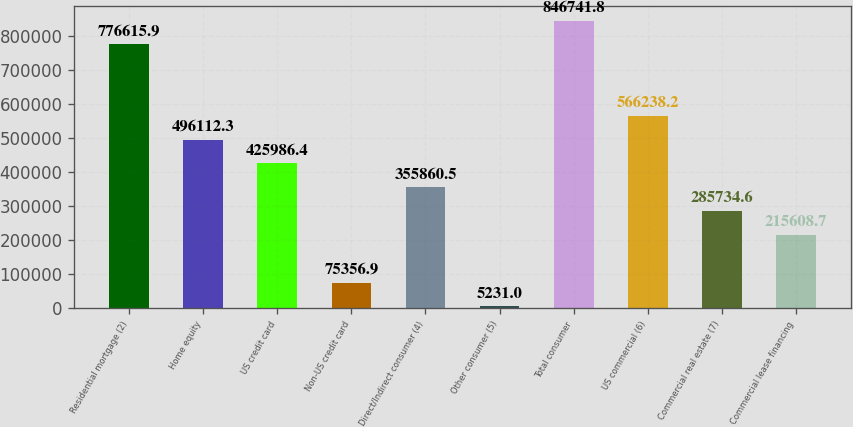Convert chart. <chart><loc_0><loc_0><loc_500><loc_500><bar_chart><fcel>Residential mortgage (2)<fcel>Home equity<fcel>US credit card<fcel>Non-US credit card<fcel>Direct/Indirect consumer (4)<fcel>Other consumer (5)<fcel>Total consumer<fcel>US commercial (6)<fcel>Commercial real estate (7)<fcel>Commercial lease financing<nl><fcel>776616<fcel>496112<fcel>425986<fcel>75356.9<fcel>355860<fcel>5231<fcel>846742<fcel>566238<fcel>285735<fcel>215609<nl></chart> 